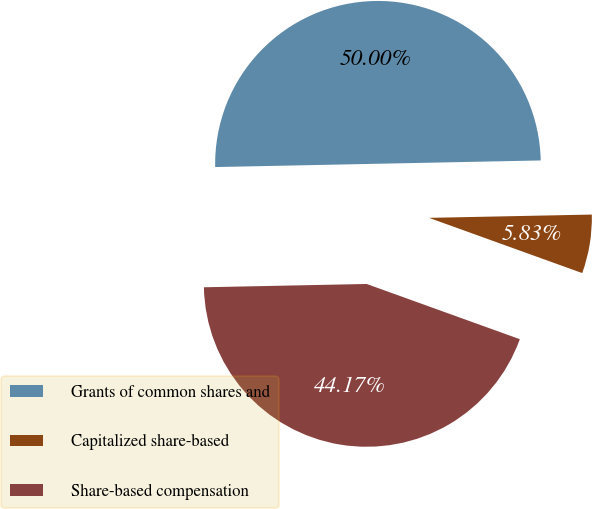<chart> <loc_0><loc_0><loc_500><loc_500><pie_chart><fcel>Grants of common shares and<fcel>Capitalized share-based<fcel>Share-based compensation<nl><fcel>50.0%<fcel>5.83%<fcel>44.17%<nl></chart> 